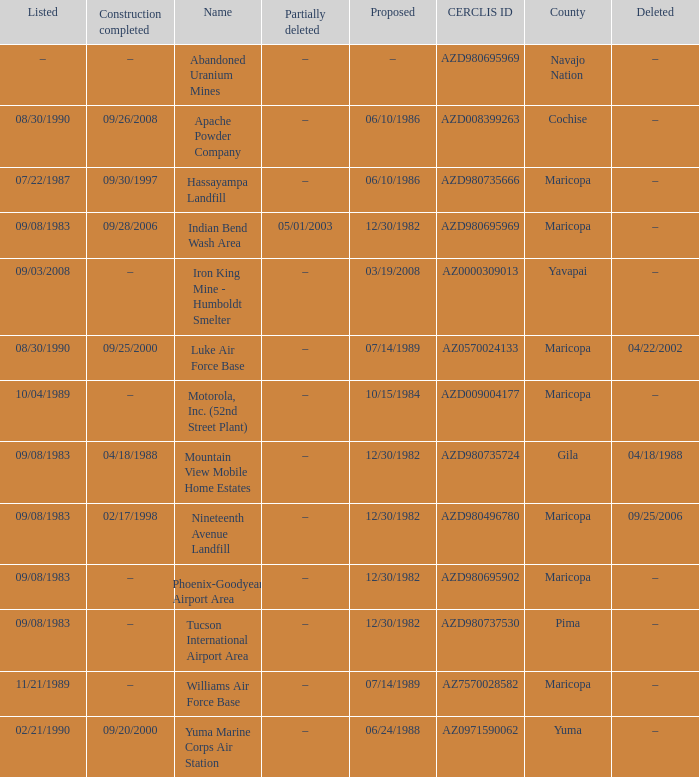When was the site listed when the county is cochise? 08/30/1990. 